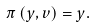Convert formula to latex. <formula><loc_0><loc_0><loc_500><loc_500>\pi \left ( y , v \right ) = y .</formula> 